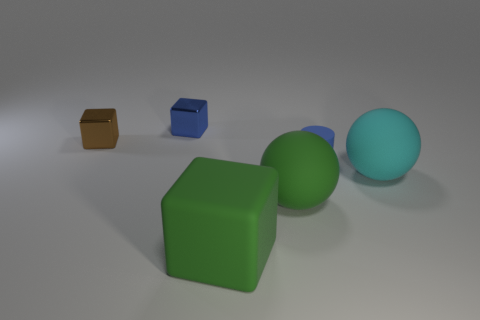What is the size of the brown thing?
Give a very brief answer. Small. There is a blue object that is made of the same material as the big green ball; what shape is it?
Your answer should be very brief. Cylinder. Does the tiny blue thing in front of the brown cube have the same shape as the cyan rubber object?
Provide a succinct answer. No. How many objects are either tiny blue things or big cyan rubber objects?
Your answer should be very brief. 3. What is the material of the small object that is both to the right of the brown cube and left of the small matte thing?
Keep it short and to the point. Metal. Is the size of the blue cylinder the same as the blue cube?
Your response must be concise. Yes. There is a blue thing in front of the thing that is behind the tiny brown block; what is its size?
Offer a very short reply. Small. What number of objects are both behind the green rubber sphere and to the right of the brown thing?
Keep it short and to the point. 3. Are there any small brown metal cubes that are right of the matte sphere that is in front of the big object right of the blue cylinder?
Offer a very short reply. No. What shape is the blue rubber thing that is the same size as the brown metal object?
Keep it short and to the point. Cylinder. 